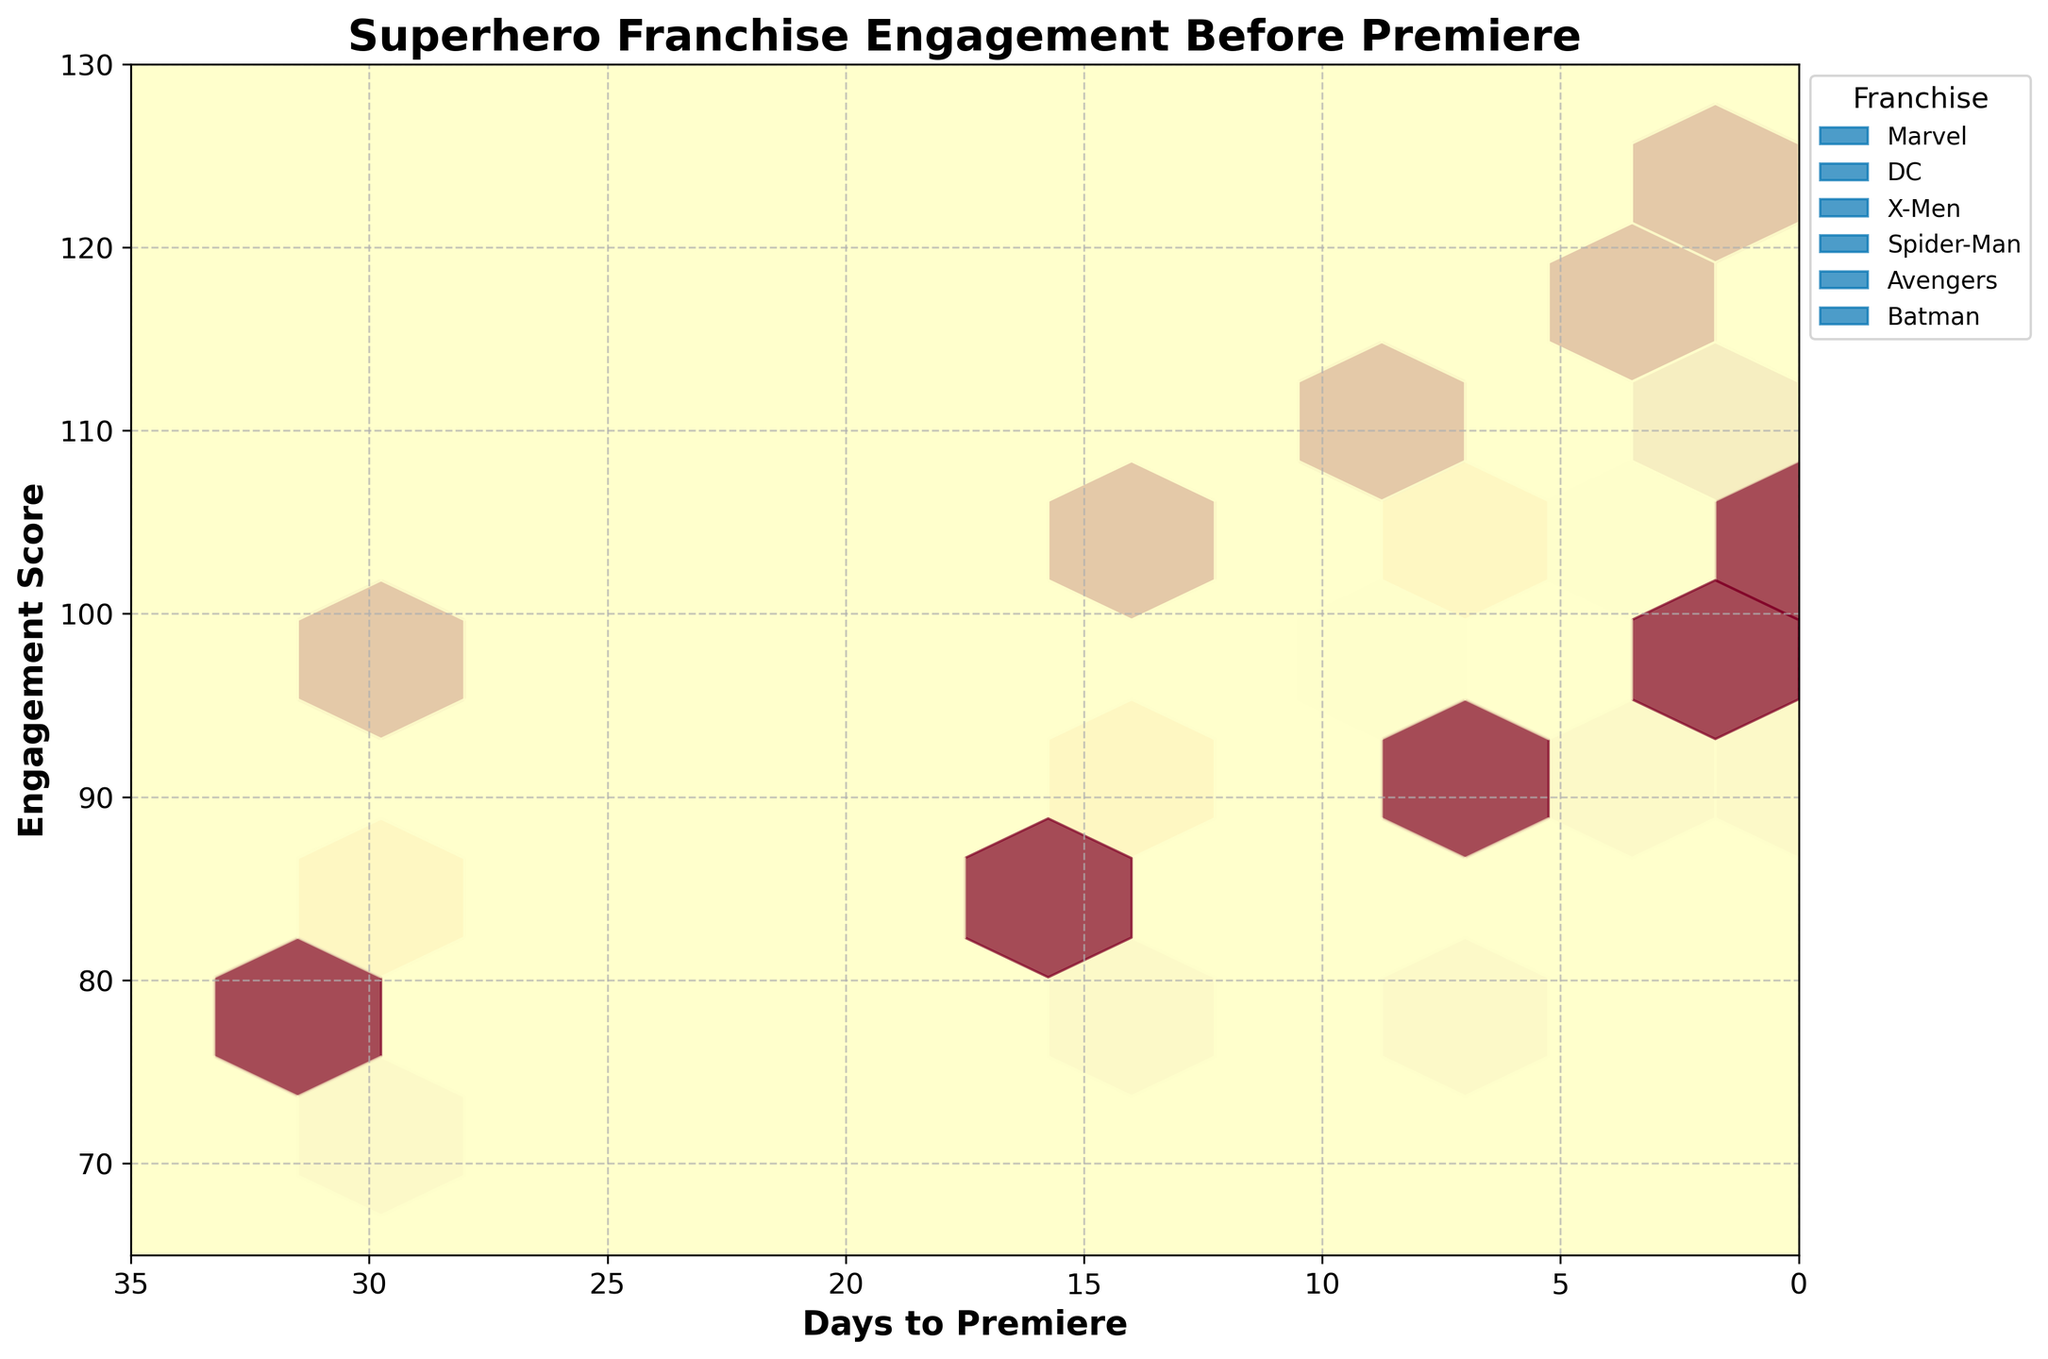what is the title of the figure? The title is displayed at the top of the figure. It's intended to provide a brief summary of what the hexbin plot depicts. In this case, it explains that the plot shows the engagement levels of superhero franchises leading up to their premieres.
Answer: Superhero Franchise Engagement Before Premiere which franchise has the highest engagement score close to the premiere date? Look for the hexbin with the highest engagement score closest to 0 days to the premiere on the x-axis. The hexbin representing the Avengers franchise has engagement scores reaching up to 125 near the premiere.
Answer: Avengers what's the trend observed in the data as the premiere date approaches? Analyze how the data points and color intensity change as the days to premiere decrease. Generally, there's an increase in engagement score (intensity) as days to premiere get closer to 0.
Answer: Engagement scores increase compare the engagement score of Marvel and DC franchises 1 day before premiere. Which one is higher? Locate the hexbin cells around 1 day to the premiere on the x-axis for both Marvel and DC. Compare the values - Marvel has an engagement score around 110 and DC around 100.
Answer: Marvel how many different superhero franchises are shown in the plot? Count the number of unique franchises listed in the legend on the right side of the figure.
Answer: Six which two franchises have engagement scores that seem the closest in the final 3 days before the premiere? Look at the hexbin intensities and values closer to 3 days to 0 days in the x-axis. Both Batman and DC show similar lower engagement scores around 100-105.
Answer: Batman and DC what's the lower limit of the engagement score shown in the plot? Identify the smallest value on the y-axis labeled as Engagement Score.
Answer: 65 which franchise shows the fastest rise in engagement as the premiere approaches? Analyze the gradient and changes in the hexbin color intensity as the days to the premiere decrease. Avengers show a remarkably steep rise.
Answer: Avengers what's the general range of engagement scores for the Spider-Man franchise 15 days before the premiere? Identify the hexbin cells around 15 days to the premiere on the x-axis and check the range of engagement scores for Spider-Man. The range is approximately 94.
Answer: 94 